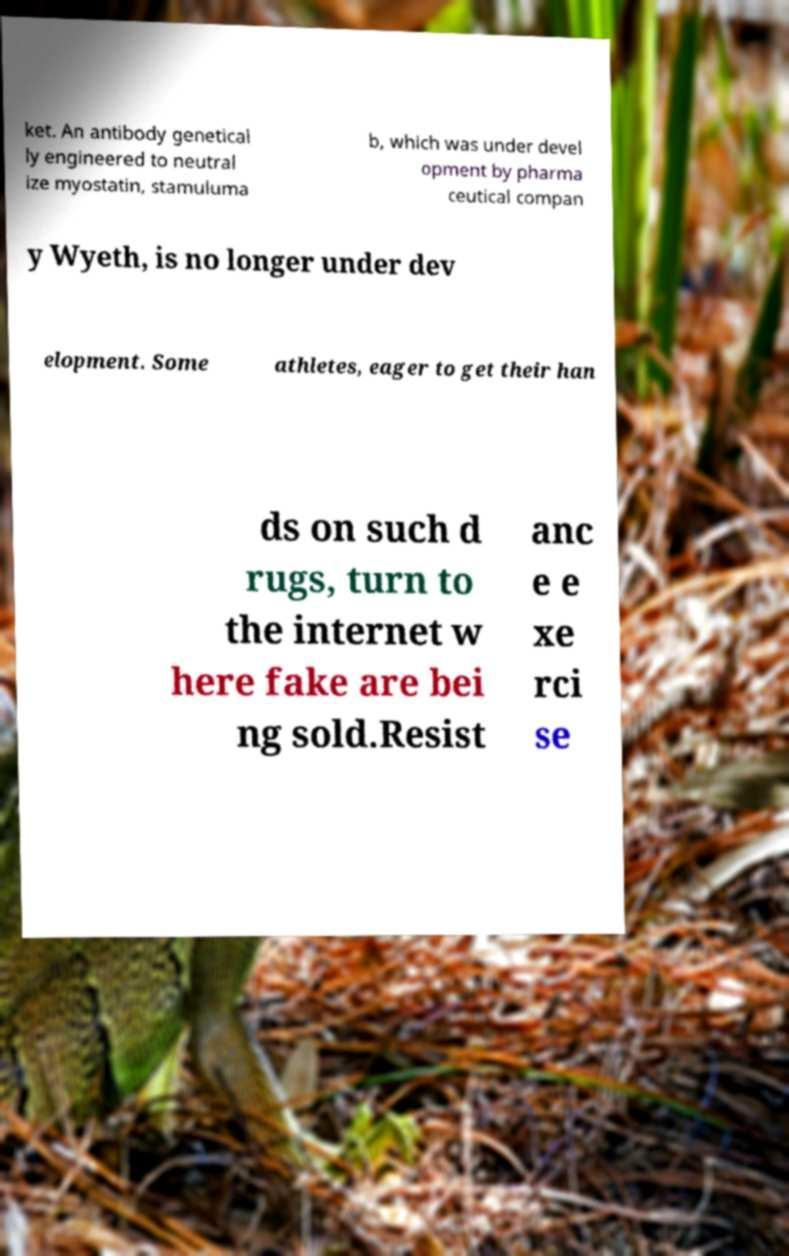Can you accurately transcribe the text from the provided image for me? ket. An antibody genetical ly engineered to neutral ize myostatin, stamuluma b, which was under devel opment by pharma ceutical compan y Wyeth, is no longer under dev elopment. Some athletes, eager to get their han ds on such d rugs, turn to the internet w here fake are bei ng sold.Resist anc e e xe rci se 